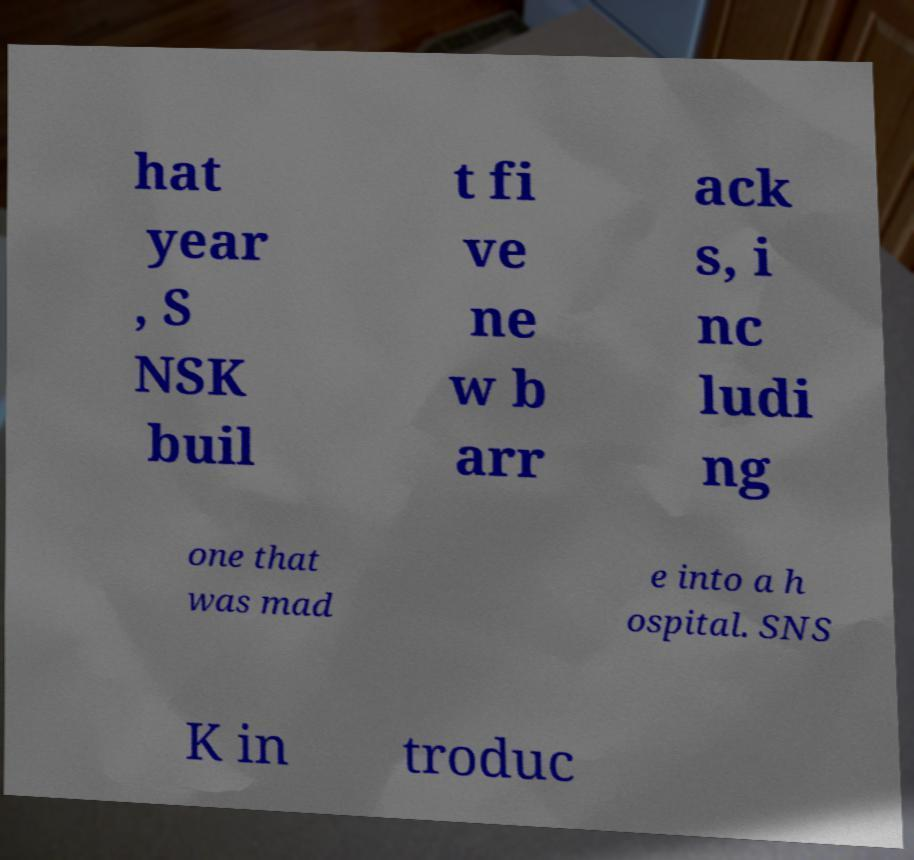Can you accurately transcribe the text from the provided image for me? hat year , S NSK buil t fi ve ne w b arr ack s, i nc ludi ng one that was mad e into a h ospital. SNS K in troduc 